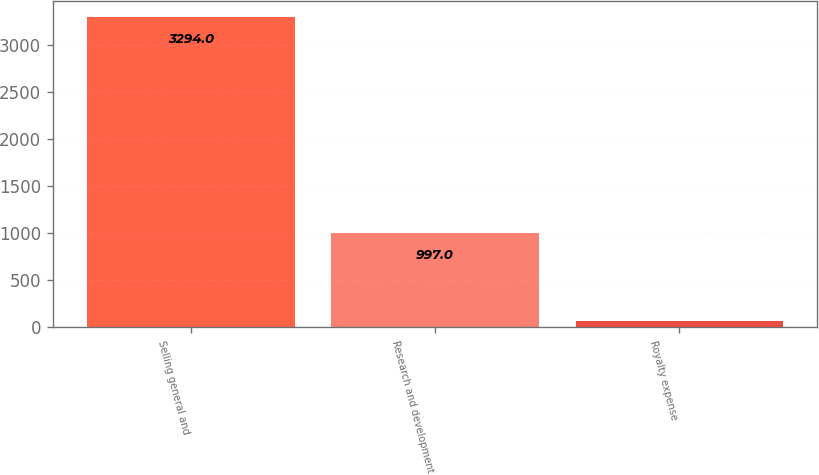Convert chart. <chart><loc_0><loc_0><loc_500><loc_500><bar_chart><fcel>Selling general and<fcel>Research and development<fcel>Royalty expense<nl><fcel>3294<fcel>997<fcel>68<nl></chart> 